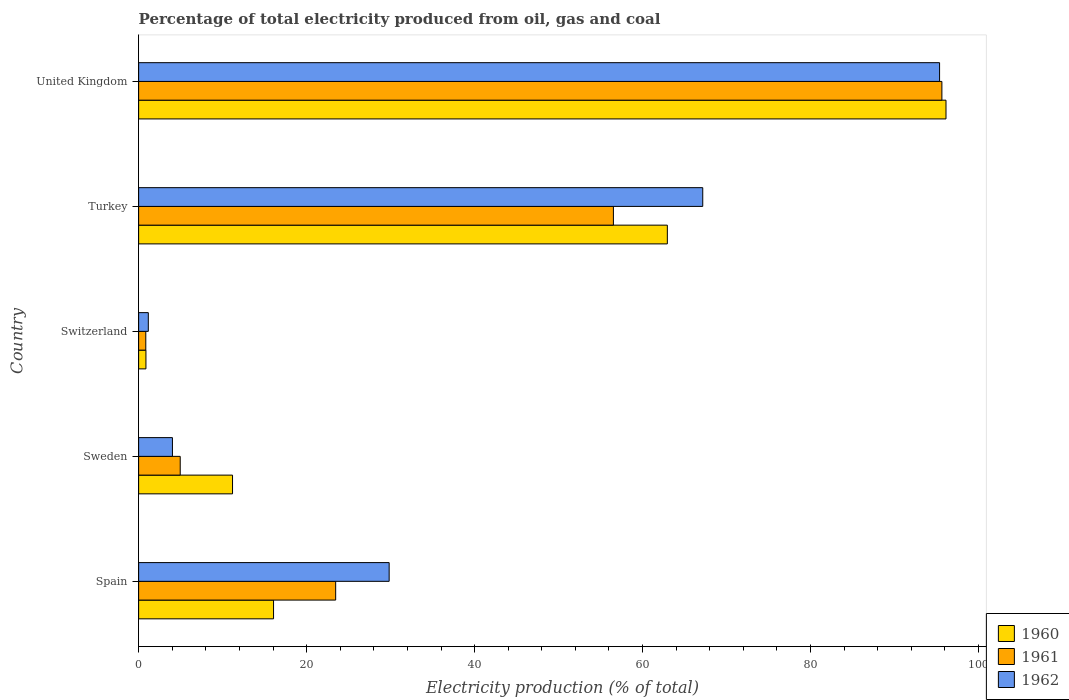Are the number of bars per tick equal to the number of legend labels?
Make the answer very short. Yes. How many bars are there on the 4th tick from the top?
Ensure brevity in your answer.  3. What is the label of the 5th group of bars from the top?
Offer a very short reply. Spain. In how many cases, is the number of bars for a given country not equal to the number of legend labels?
Your answer should be very brief. 0. What is the electricity production in in 1961 in United Kingdom?
Provide a short and direct response. 95.64. Across all countries, what is the maximum electricity production in in 1961?
Your response must be concise. 95.64. Across all countries, what is the minimum electricity production in in 1962?
Your answer should be compact. 1.15. In which country was the electricity production in in 1960 maximum?
Provide a succinct answer. United Kingdom. In which country was the electricity production in in 1961 minimum?
Give a very brief answer. Switzerland. What is the total electricity production in in 1960 in the graph?
Your response must be concise. 187.19. What is the difference between the electricity production in in 1962 in Spain and that in United Kingdom?
Your answer should be very brief. -65.53. What is the difference between the electricity production in in 1961 in Spain and the electricity production in in 1960 in Turkey?
Offer a terse response. -39.49. What is the average electricity production in in 1960 per country?
Ensure brevity in your answer.  37.44. What is the difference between the electricity production in in 1961 and electricity production in in 1960 in Spain?
Keep it short and to the point. 7.4. What is the ratio of the electricity production in in 1960 in Spain to that in Turkey?
Offer a terse response. 0.26. What is the difference between the highest and the second highest electricity production in in 1960?
Your answer should be compact. 33.18. What is the difference between the highest and the lowest electricity production in in 1960?
Provide a succinct answer. 95.25. Is the sum of the electricity production in in 1960 in Spain and Turkey greater than the maximum electricity production in in 1961 across all countries?
Give a very brief answer. No. What does the 3rd bar from the bottom in Spain represents?
Ensure brevity in your answer.  1962. Is it the case that in every country, the sum of the electricity production in in 1961 and electricity production in in 1960 is greater than the electricity production in in 1962?
Make the answer very short. Yes. What is the difference between two consecutive major ticks on the X-axis?
Offer a terse response. 20. Does the graph contain grids?
Give a very brief answer. No. Where does the legend appear in the graph?
Offer a terse response. Bottom right. How are the legend labels stacked?
Make the answer very short. Vertical. What is the title of the graph?
Your response must be concise. Percentage of total electricity produced from oil, gas and coal. Does "2010" appear as one of the legend labels in the graph?
Offer a terse response. No. What is the label or title of the X-axis?
Offer a very short reply. Electricity production (% of total). What is the Electricity production (% of total) in 1960 in Spain?
Offer a terse response. 16.06. What is the Electricity production (% of total) in 1961 in Spain?
Your answer should be very brief. 23.46. What is the Electricity production (% of total) in 1962 in Spain?
Your answer should be compact. 29.83. What is the Electricity production (% of total) of 1960 in Sweden?
Your response must be concise. 11.18. What is the Electricity production (% of total) in 1961 in Sweden?
Offer a terse response. 4.95. What is the Electricity production (% of total) of 1962 in Sweden?
Offer a very short reply. 4.02. What is the Electricity production (% of total) in 1960 in Switzerland?
Your answer should be compact. 0.87. What is the Electricity production (% of total) of 1961 in Switzerland?
Your answer should be very brief. 0.85. What is the Electricity production (% of total) of 1962 in Switzerland?
Your answer should be compact. 1.15. What is the Electricity production (% of total) in 1960 in Turkey?
Provide a succinct answer. 62.95. What is the Electricity production (% of total) in 1961 in Turkey?
Offer a terse response. 56.53. What is the Electricity production (% of total) of 1962 in Turkey?
Provide a succinct answer. 67.16. What is the Electricity production (% of total) of 1960 in United Kingdom?
Keep it short and to the point. 96.12. What is the Electricity production (% of total) in 1961 in United Kingdom?
Make the answer very short. 95.64. What is the Electricity production (% of total) of 1962 in United Kingdom?
Ensure brevity in your answer.  95.36. Across all countries, what is the maximum Electricity production (% of total) in 1960?
Your answer should be very brief. 96.12. Across all countries, what is the maximum Electricity production (% of total) of 1961?
Make the answer very short. 95.64. Across all countries, what is the maximum Electricity production (% of total) of 1962?
Ensure brevity in your answer.  95.36. Across all countries, what is the minimum Electricity production (% of total) in 1960?
Provide a short and direct response. 0.87. Across all countries, what is the minimum Electricity production (% of total) in 1961?
Your answer should be compact. 0.85. Across all countries, what is the minimum Electricity production (% of total) in 1962?
Offer a terse response. 1.15. What is the total Electricity production (% of total) in 1960 in the graph?
Ensure brevity in your answer.  187.19. What is the total Electricity production (% of total) of 1961 in the graph?
Your response must be concise. 181.43. What is the total Electricity production (% of total) of 1962 in the graph?
Provide a short and direct response. 197.53. What is the difference between the Electricity production (% of total) in 1960 in Spain and that in Sweden?
Offer a very short reply. 4.88. What is the difference between the Electricity production (% of total) in 1961 in Spain and that in Sweden?
Give a very brief answer. 18.51. What is the difference between the Electricity production (% of total) in 1962 in Spain and that in Sweden?
Your answer should be compact. 25.8. What is the difference between the Electricity production (% of total) of 1960 in Spain and that in Switzerland?
Your answer should be compact. 15.19. What is the difference between the Electricity production (% of total) of 1961 in Spain and that in Switzerland?
Your response must be concise. 22.61. What is the difference between the Electricity production (% of total) in 1962 in Spain and that in Switzerland?
Your answer should be very brief. 28.67. What is the difference between the Electricity production (% of total) in 1960 in Spain and that in Turkey?
Make the answer very short. -46.89. What is the difference between the Electricity production (% of total) of 1961 in Spain and that in Turkey?
Make the answer very short. -33.07. What is the difference between the Electricity production (% of total) of 1962 in Spain and that in Turkey?
Provide a short and direct response. -37.34. What is the difference between the Electricity production (% of total) in 1960 in Spain and that in United Kingdom?
Offer a very short reply. -80.06. What is the difference between the Electricity production (% of total) of 1961 in Spain and that in United Kingdom?
Your answer should be very brief. -72.18. What is the difference between the Electricity production (% of total) in 1962 in Spain and that in United Kingdom?
Your response must be concise. -65.53. What is the difference between the Electricity production (% of total) of 1960 in Sweden and that in Switzerland?
Offer a terse response. 10.31. What is the difference between the Electricity production (% of total) in 1961 in Sweden and that in Switzerland?
Provide a succinct answer. 4.1. What is the difference between the Electricity production (% of total) in 1962 in Sweden and that in Switzerland?
Provide a succinct answer. 2.87. What is the difference between the Electricity production (% of total) in 1960 in Sweden and that in Turkey?
Give a very brief answer. -51.77. What is the difference between the Electricity production (% of total) of 1961 in Sweden and that in Turkey?
Ensure brevity in your answer.  -51.57. What is the difference between the Electricity production (% of total) of 1962 in Sweden and that in Turkey?
Your answer should be very brief. -63.14. What is the difference between the Electricity production (% of total) of 1960 in Sweden and that in United Kingdom?
Your response must be concise. -84.94. What is the difference between the Electricity production (% of total) of 1961 in Sweden and that in United Kingdom?
Keep it short and to the point. -90.68. What is the difference between the Electricity production (% of total) in 1962 in Sweden and that in United Kingdom?
Provide a short and direct response. -91.34. What is the difference between the Electricity production (% of total) in 1960 in Switzerland and that in Turkey?
Provide a short and direct response. -62.08. What is the difference between the Electricity production (% of total) of 1961 in Switzerland and that in Turkey?
Offer a terse response. -55.67. What is the difference between the Electricity production (% of total) in 1962 in Switzerland and that in Turkey?
Your response must be concise. -66.01. What is the difference between the Electricity production (% of total) in 1960 in Switzerland and that in United Kingdom?
Your answer should be very brief. -95.25. What is the difference between the Electricity production (% of total) in 1961 in Switzerland and that in United Kingdom?
Your answer should be very brief. -94.78. What is the difference between the Electricity production (% of total) in 1962 in Switzerland and that in United Kingdom?
Make the answer very short. -94.21. What is the difference between the Electricity production (% of total) in 1960 in Turkey and that in United Kingdom?
Offer a very short reply. -33.18. What is the difference between the Electricity production (% of total) of 1961 in Turkey and that in United Kingdom?
Ensure brevity in your answer.  -39.11. What is the difference between the Electricity production (% of total) in 1962 in Turkey and that in United Kingdom?
Provide a short and direct response. -28.2. What is the difference between the Electricity production (% of total) of 1960 in Spain and the Electricity production (% of total) of 1961 in Sweden?
Offer a terse response. 11.11. What is the difference between the Electricity production (% of total) of 1960 in Spain and the Electricity production (% of total) of 1962 in Sweden?
Make the answer very short. 12.04. What is the difference between the Electricity production (% of total) in 1961 in Spain and the Electricity production (% of total) in 1962 in Sweden?
Provide a short and direct response. 19.44. What is the difference between the Electricity production (% of total) of 1960 in Spain and the Electricity production (% of total) of 1961 in Switzerland?
Offer a very short reply. 15.21. What is the difference between the Electricity production (% of total) of 1960 in Spain and the Electricity production (% of total) of 1962 in Switzerland?
Give a very brief answer. 14.91. What is the difference between the Electricity production (% of total) of 1961 in Spain and the Electricity production (% of total) of 1962 in Switzerland?
Make the answer very short. 22.31. What is the difference between the Electricity production (% of total) of 1960 in Spain and the Electricity production (% of total) of 1961 in Turkey?
Offer a very short reply. -40.46. What is the difference between the Electricity production (% of total) in 1960 in Spain and the Electricity production (% of total) in 1962 in Turkey?
Give a very brief answer. -51.1. What is the difference between the Electricity production (% of total) of 1961 in Spain and the Electricity production (% of total) of 1962 in Turkey?
Ensure brevity in your answer.  -43.7. What is the difference between the Electricity production (% of total) in 1960 in Spain and the Electricity production (% of total) in 1961 in United Kingdom?
Ensure brevity in your answer.  -79.57. What is the difference between the Electricity production (% of total) in 1960 in Spain and the Electricity production (% of total) in 1962 in United Kingdom?
Offer a very short reply. -79.3. What is the difference between the Electricity production (% of total) of 1961 in Spain and the Electricity production (% of total) of 1962 in United Kingdom?
Provide a short and direct response. -71.9. What is the difference between the Electricity production (% of total) of 1960 in Sweden and the Electricity production (% of total) of 1961 in Switzerland?
Provide a succinct answer. 10.33. What is the difference between the Electricity production (% of total) in 1960 in Sweden and the Electricity production (% of total) in 1962 in Switzerland?
Keep it short and to the point. 10.03. What is the difference between the Electricity production (% of total) of 1961 in Sweden and the Electricity production (% of total) of 1962 in Switzerland?
Ensure brevity in your answer.  3.8. What is the difference between the Electricity production (% of total) in 1960 in Sweden and the Electricity production (% of total) in 1961 in Turkey?
Give a very brief answer. -45.35. What is the difference between the Electricity production (% of total) of 1960 in Sweden and the Electricity production (% of total) of 1962 in Turkey?
Your response must be concise. -55.98. What is the difference between the Electricity production (% of total) in 1961 in Sweden and the Electricity production (% of total) in 1962 in Turkey?
Offer a very short reply. -62.21. What is the difference between the Electricity production (% of total) in 1960 in Sweden and the Electricity production (% of total) in 1961 in United Kingdom?
Ensure brevity in your answer.  -84.46. What is the difference between the Electricity production (% of total) in 1960 in Sweden and the Electricity production (% of total) in 1962 in United Kingdom?
Your answer should be very brief. -84.18. What is the difference between the Electricity production (% of total) of 1961 in Sweden and the Electricity production (% of total) of 1962 in United Kingdom?
Ensure brevity in your answer.  -90.41. What is the difference between the Electricity production (% of total) of 1960 in Switzerland and the Electricity production (% of total) of 1961 in Turkey?
Offer a terse response. -55.66. What is the difference between the Electricity production (% of total) of 1960 in Switzerland and the Electricity production (% of total) of 1962 in Turkey?
Your answer should be very brief. -66.29. What is the difference between the Electricity production (% of total) of 1961 in Switzerland and the Electricity production (% of total) of 1962 in Turkey?
Provide a short and direct response. -66.31. What is the difference between the Electricity production (% of total) in 1960 in Switzerland and the Electricity production (% of total) in 1961 in United Kingdom?
Your response must be concise. -94.77. What is the difference between the Electricity production (% of total) in 1960 in Switzerland and the Electricity production (% of total) in 1962 in United Kingdom?
Your answer should be very brief. -94.49. What is the difference between the Electricity production (% of total) in 1961 in Switzerland and the Electricity production (% of total) in 1962 in United Kingdom?
Your response must be concise. -94.51. What is the difference between the Electricity production (% of total) of 1960 in Turkey and the Electricity production (% of total) of 1961 in United Kingdom?
Ensure brevity in your answer.  -32.69. What is the difference between the Electricity production (% of total) of 1960 in Turkey and the Electricity production (% of total) of 1962 in United Kingdom?
Your answer should be compact. -32.41. What is the difference between the Electricity production (% of total) of 1961 in Turkey and the Electricity production (% of total) of 1962 in United Kingdom?
Provide a short and direct response. -38.83. What is the average Electricity production (% of total) of 1960 per country?
Ensure brevity in your answer.  37.44. What is the average Electricity production (% of total) in 1961 per country?
Give a very brief answer. 36.29. What is the average Electricity production (% of total) in 1962 per country?
Your answer should be very brief. 39.51. What is the difference between the Electricity production (% of total) in 1960 and Electricity production (% of total) in 1961 in Spain?
Offer a terse response. -7.4. What is the difference between the Electricity production (% of total) in 1960 and Electricity production (% of total) in 1962 in Spain?
Provide a succinct answer. -13.76. What is the difference between the Electricity production (% of total) in 1961 and Electricity production (% of total) in 1962 in Spain?
Give a very brief answer. -6.37. What is the difference between the Electricity production (% of total) in 1960 and Electricity production (% of total) in 1961 in Sweden?
Offer a terse response. 6.23. What is the difference between the Electricity production (% of total) in 1960 and Electricity production (% of total) in 1962 in Sweden?
Offer a very short reply. 7.16. What is the difference between the Electricity production (% of total) in 1961 and Electricity production (% of total) in 1962 in Sweden?
Offer a terse response. 0.93. What is the difference between the Electricity production (% of total) of 1960 and Electricity production (% of total) of 1961 in Switzerland?
Offer a very short reply. 0.02. What is the difference between the Electricity production (% of total) of 1960 and Electricity production (% of total) of 1962 in Switzerland?
Keep it short and to the point. -0.28. What is the difference between the Electricity production (% of total) of 1961 and Electricity production (% of total) of 1962 in Switzerland?
Provide a succinct answer. -0.3. What is the difference between the Electricity production (% of total) in 1960 and Electricity production (% of total) in 1961 in Turkey?
Your answer should be compact. 6.42. What is the difference between the Electricity production (% of total) of 1960 and Electricity production (% of total) of 1962 in Turkey?
Give a very brief answer. -4.21. What is the difference between the Electricity production (% of total) in 1961 and Electricity production (% of total) in 1962 in Turkey?
Keep it short and to the point. -10.64. What is the difference between the Electricity production (% of total) in 1960 and Electricity production (% of total) in 1961 in United Kingdom?
Provide a short and direct response. 0.49. What is the difference between the Electricity production (% of total) in 1960 and Electricity production (% of total) in 1962 in United Kingdom?
Your answer should be very brief. 0.76. What is the difference between the Electricity production (% of total) in 1961 and Electricity production (% of total) in 1962 in United Kingdom?
Your answer should be compact. 0.28. What is the ratio of the Electricity production (% of total) of 1960 in Spain to that in Sweden?
Ensure brevity in your answer.  1.44. What is the ratio of the Electricity production (% of total) in 1961 in Spain to that in Sweden?
Offer a terse response. 4.74. What is the ratio of the Electricity production (% of total) of 1962 in Spain to that in Sweden?
Ensure brevity in your answer.  7.41. What is the ratio of the Electricity production (% of total) in 1960 in Spain to that in Switzerland?
Your response must be concise. 18.47. What is the ratio of the Electricity production (% of total) in 1961 in Spain to that in Switzerland?
Provide a short and direct response. 27.48. What is the ratio of the Electricity production (% of total) of 1962 in Spain to that in Switzerland?
Offer a terse response. 25.86. What is the ratio of the Electricity production (% of total) in 1960 in Spain to that in Turkey?
Ensure brevity in your answer.  0.26. What is the ratio of the Electricity production (% of total) in 1961 in Spain to that in Turkey?
Your answer should be compact. 0.41. What is the ratio of the Electricity production (% of total) of 1962 in Spain to that in Turkey?
Your answer should be compact. 0.44. What is the ratio of the Electricity production (% of total) in 1960 in Spain to that in United Kingdom?
Your answer should be very brief. 0.17. What is the ratio of the Electricity production (% of total) of 1961 in Spain to that in United Kingdom?
Your response must be concise. 0.25. What is the ratio of the Electricity production (% of total) in 1962 in Spain to that in United Kingdom?
Your answer should be very brief. 0.31. What is the ratio of the Electricity production (% of total) in 1960 in Sweden to that in Switzerland?
Your answer should be compact. 12.86. What is the ratio of the Electricity production (% of total) in 1961 in Sweden to that in Switzerland?
Your response must be concise. 5.8. What is the ratio of the Electricity production (% of total) of 1962 in Sweden to that in Switzerland?
Provide a succinct answer. 3.49. What is the ratio of the Electricity production (% of total) in 1960 in Sweden to that in Turkey?
Give a very brief answer. 0.18. What is the ratio of the Electricity production (% of total) of 1961 in Sweden to that in Turkey?
Give a very brief answer. 0.09. What is the ratio of the Electricity production (% of total) in 1962 in Sweden to that in Turkey?
Keep it short and to the point. 0.06. What is the ratio of the Electricity production (% of total) in 1960 in Sweden to that in United Kingdom?
Your answer should be compact. 0.12. What is the ratio of the Electricity production (% of total) in 1961 in Sweden to that in United Kingdom?
Offer a very short reply. 0.05. What is the ratio of the Electricity production (% of total) of 1962 in Sweden to that in United Kingdom?
Offer a terse response. 0.04. What is the ratio of the Electricity production (% of total) of 1960 in Switzerland to that in Turkey?
Provide a succinct answer. 0.01. What is the ratio of the Electricity production (% of total) of 1961 in Switzerland to that in Turkey?
Your response must be concise. 0.02. What is the ratio of the Electricity production (% of total) in 1962 in Switzerland to that in Turkey?
Keep it short and to the point. 0.02. What is the ratio of the Electricity production (% of total) in 1960 in Switzerland to that in United Kingdom?
Ensure brevity in your answer.  0.01. What is the ratio of the Electricity production (% of total) of 1961 in Switzerland to that in United Kingdom?
Keep it short and to the point. 0.01. What is the ratio of the Electricity production (% of total) in 1962 in Switzerland to that in United Kingdom?
Keep it short and to the point. 0.01. What is the ratio of the Electricity production (% of total) in 1960 in Turkey to that in United Kingdom?
Provide a short and direct response. 0.65. What is the ratio of the Electricity production (% of total) of 1961 in Turkey to that in United Kingdom?
Offer a terse response. 0.59. What is the ratio of the Electricity production (% of total) in 1962 in Turkey to that in United Kingdom?
Offer a very short reply. 0.7. What is the difference between the highest and the second highest Electricity production (% of total) of 1960?
Your answer should be compact. 33.18. What is the difference between the highest and the second highest Electricity production (% of total) of 1961?
Offer a very short reply. 39.11. What is the difference between the highest and the second highest Electricity production (% of total) of 1962?
Your answer should be very brief. 28.2. What is the difference between the highest and the lowest Electricity production (% of total) in 1960?
Make the answer very short. 95.25. What is the difference between the highest and the lowest Electricity production (% of total) in 1961?
Offer a very short reply. 94.78. What is the difference between the highest and the lowest Electricity production (% of total) in 1962?
Your answer should be very brief. 94.21. 